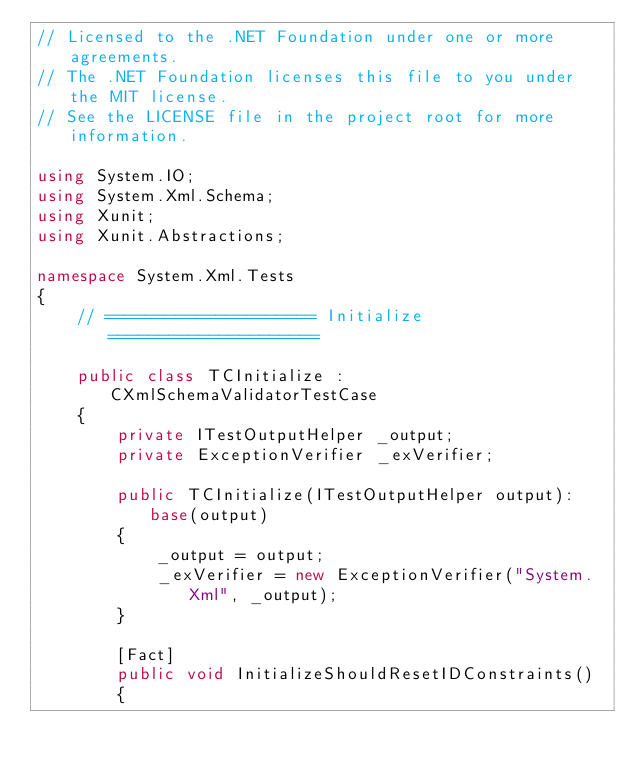Convert code to text. <code><loc_0><loc_0><loc_500><loc_500><_C#_>// Licensed to the .NET Foundation under one or more agreements.
// The .NET Foundation licenses this file to you under the MIT license.
// See the LICENSE file in the project root for more information.

using System.IO;
using System.Xml.Schema;
using Xunit;
using Xunit.Abstractions;

namespace System.Xml.Tests
{
    // ===================== Initialize =====================

    public class TCInitialize : CXmlSchemaValidatorTestCase
    {
        private ITestOutputHelper _output;
        private ExceptionVerifier _exVerifier;

        public TCInitialize(ITestOutputHelper output): base(output)
        {
            _output = output;
            _exVerifier = new ExceptionVerifier("System.Xml", _output);
        }

        [Fact]
        public void InitializeShouldResetIDConstraints()
        {</code> 